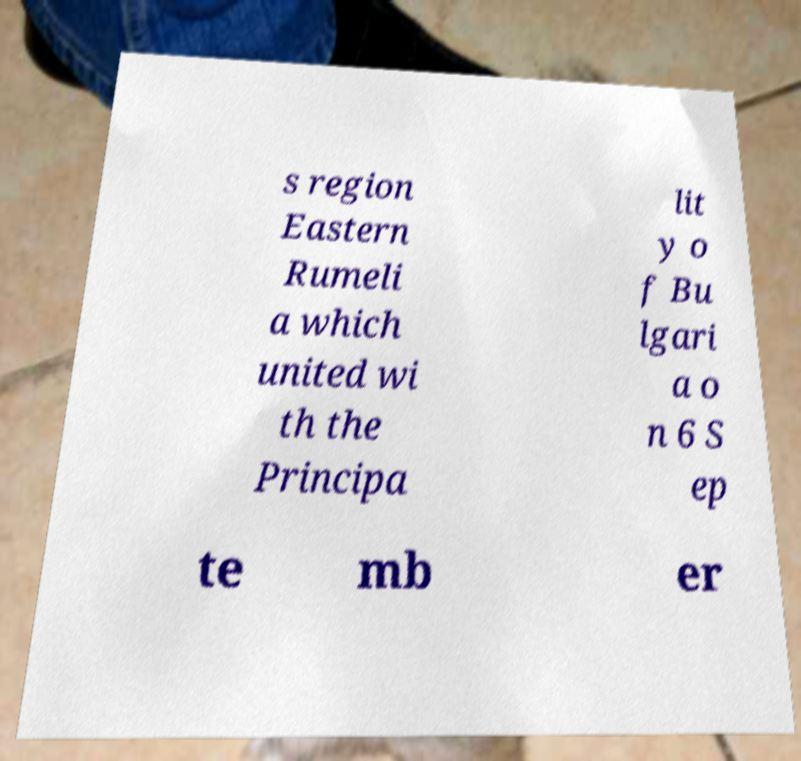For documentation purposes, I need the text within this image transcribed. Could you provide that? s region Eastern Rumeli a which united wi th the Principa lit y o f Bu lgari a o n 6 S ep te mb er 